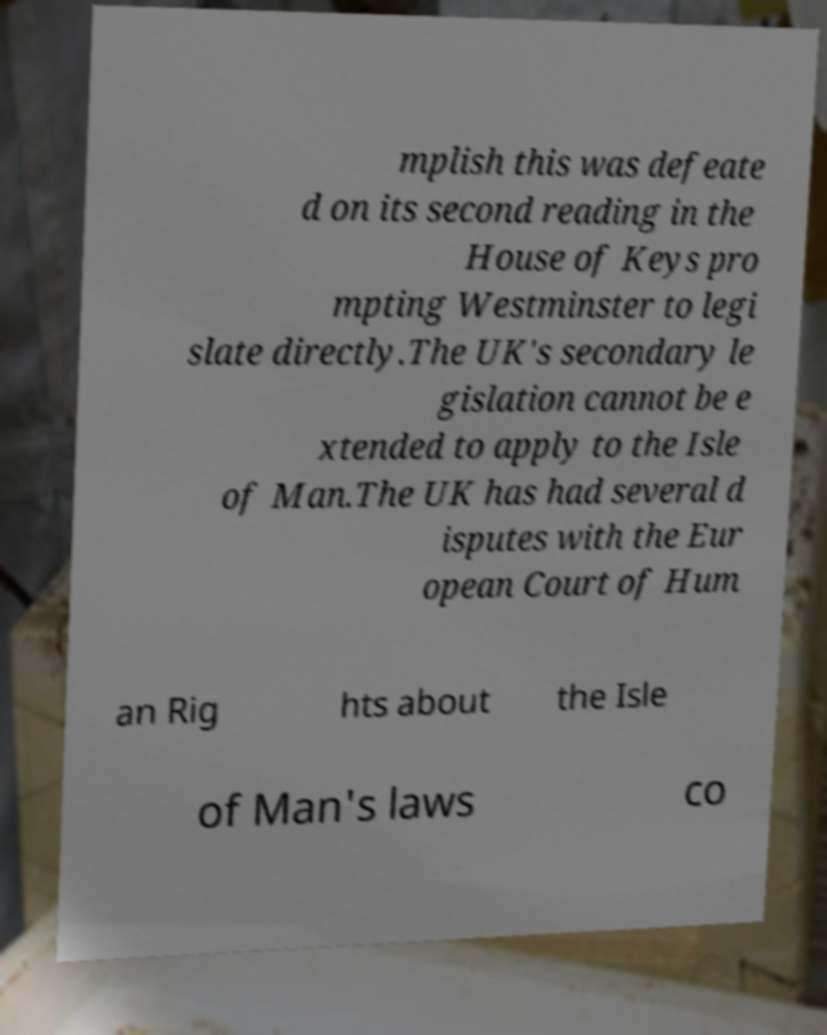What messages or text are displayed in this image? I need them in a readable, typed format. mplish this was defeate d on its second reading in the House of Keys pro mpting Westminster to legi slate directly.The UK's secondary le gislation cannot be e xtended to apply to the Isle of Man.The UK has had several d isputes with the Eur opean Court of Hum an Rig hts about the Isle of Man's laws co 